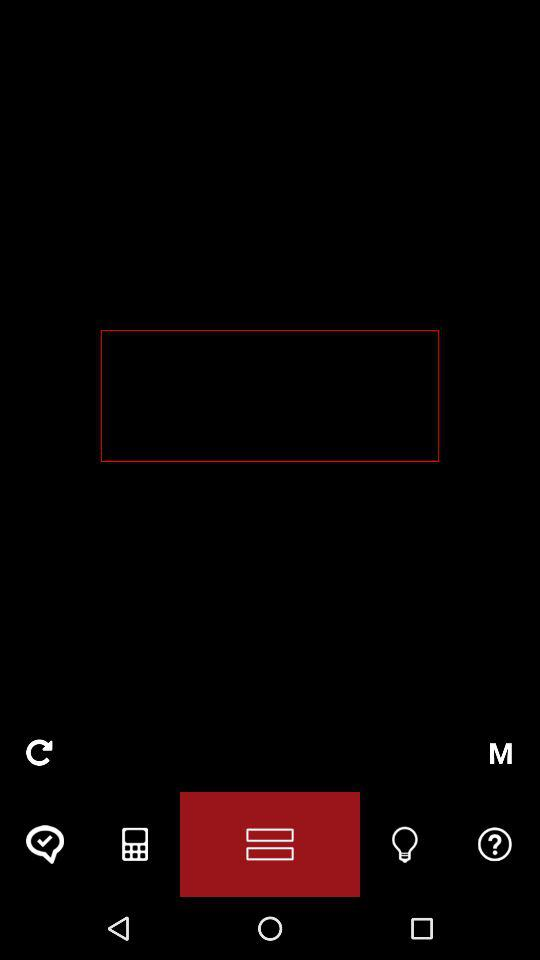What is the name of the application? The name of the application is "ask a Tutor". 